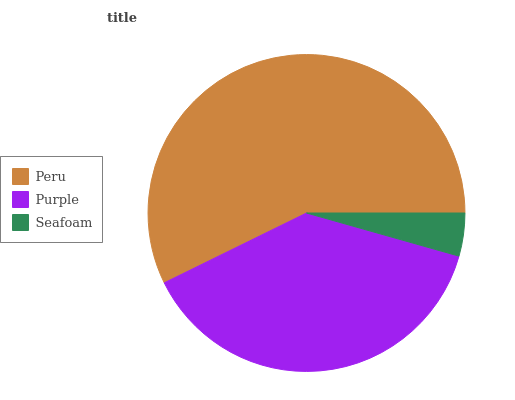Is Seafoam the minimum?
Answer yes or no. Yes. Is Peru the maximum?
Answer yes or no. Yes. Is Purple the minimum?
Answer yes or no. No. Is Purple the maximum?
Answer yes or no. No. Is Peru greater than Purple?
Answer yes or no. Yes. Is Purple less than Peru?
Answer yes or no. Yes. Is Purple greater than Peru?
Answer yes or no. No. Is Peru less than Purple?
Answer yes or no. No. Is Purple the high median?
Answer yes or no. Yes. Is Purple the low median?
Answer yes or no. Yes. Is Seafoam the high median?
Answer yes or no. No. Is Seafoam the low median?
Answer yes or no. No. 